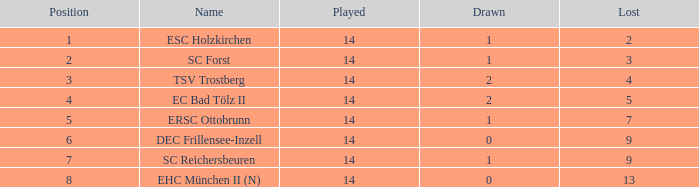How much Drawn has a Lost of 2, and Played smaller than 14? None. 